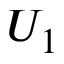<formula> <loc_0><loc_0><loc_500><loc_500>U _ { 1 }</formula> 